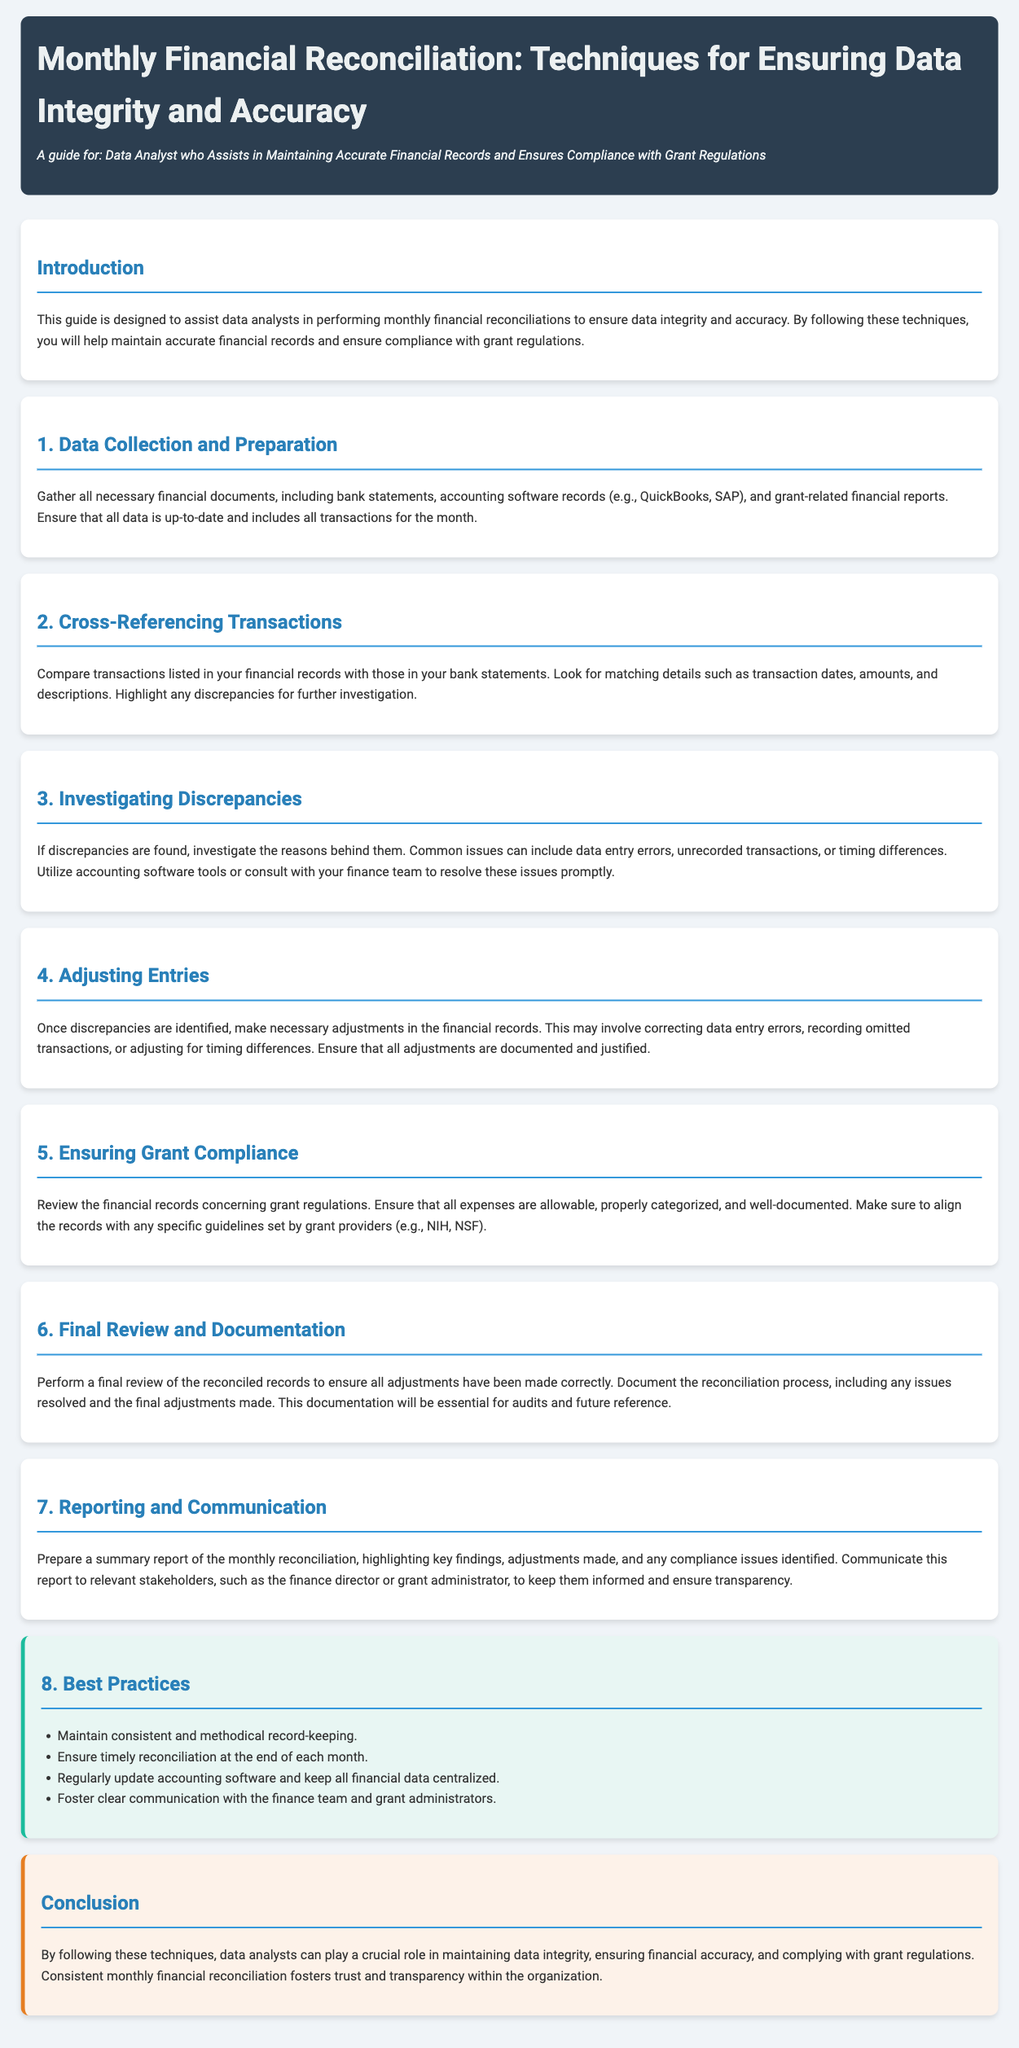what is the title of the guide? The title is presented in the header section of the document.
Answer: Monthly Financial Reconciliation: Techniques for Ensuring Data Integrity and Accuracy who is the intended audience for this guide? The intended audience is mentioned under the title in the header section.
Answer: Data Analyst who Assists in Maintaining Accurate Financial Records and Ensures Compliance with Grant Regulations what is the first step in the reconciliation process? The first step is outlined in the section titled "1. Data Collection and Preparation."
Answer: Data Collection and Preparation how many best practices are listed in the document? The number of best practices can be counted from the bulleted list under the section "8. Best Practices."
Answer: Four what should be reviewed to ensure grant compliance? This information is provided in the section titled "5. Ensuring Grant Compliance."
Answer: Financial records what is the purpose of documenting the reconciliation process? The reason for documentation is found in the "6. Final Review and Documentation" section.
Answer: Essential for audits and future reference which section discusses investigating discrepancies? This is specified in the section header.
Answer: 3. Investigating Discrepancies what is recommended for communication with the finance team? This recommendation is found in the best practices section.
Answer: Foster clear communication with the finance team and grant administrators 